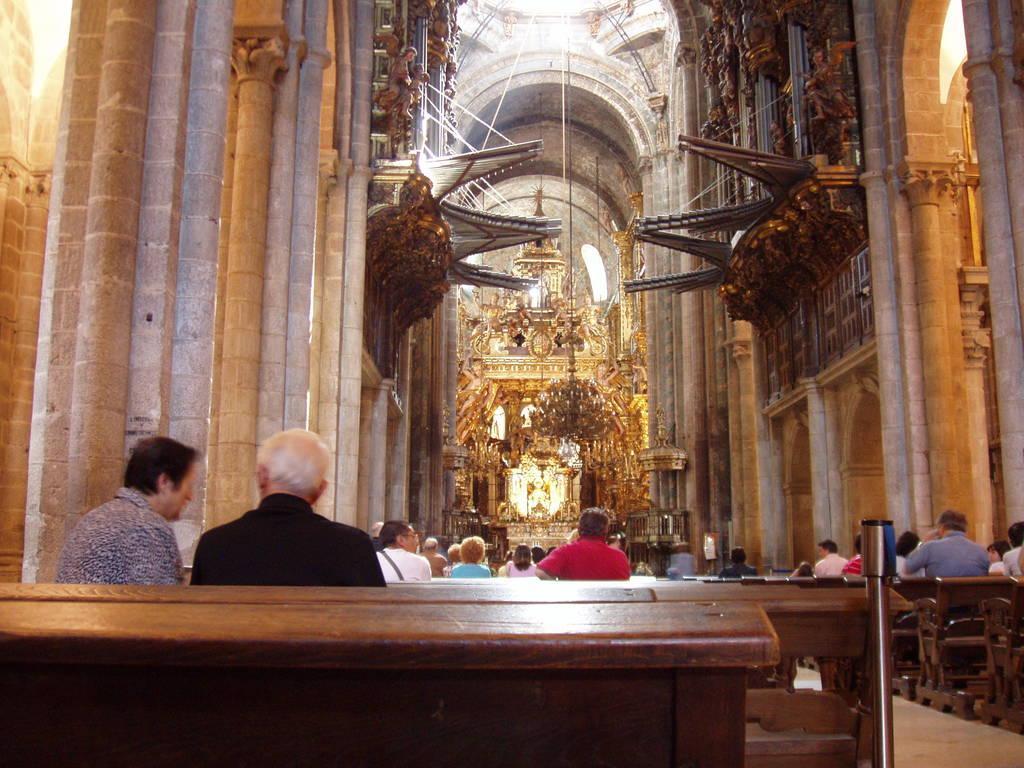Can you describe this image briefly? Here we can see an inside view of a building, there are some people sitting on benches, in the background we can see a chandelier. 